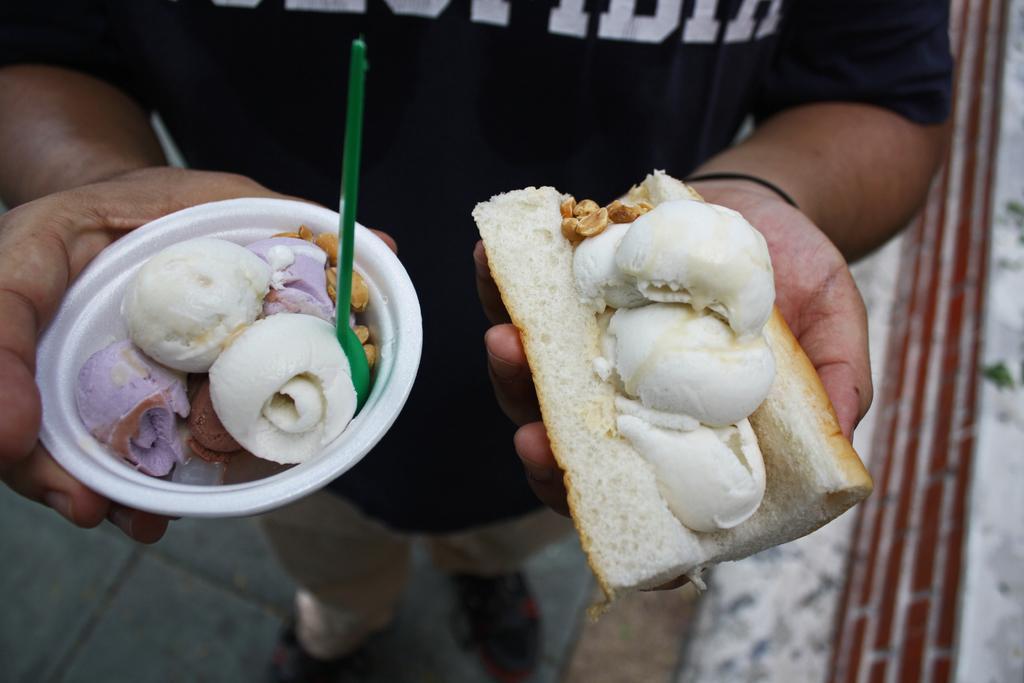Please provide a concise description of this image. In this image a person is holding a bowl with one hand and holding bread with other hand. He is wearing black shirt. He is standing on the floor. In bowl there is some ice cream and a spoon in it. Bread is stuffed with some food in it. 